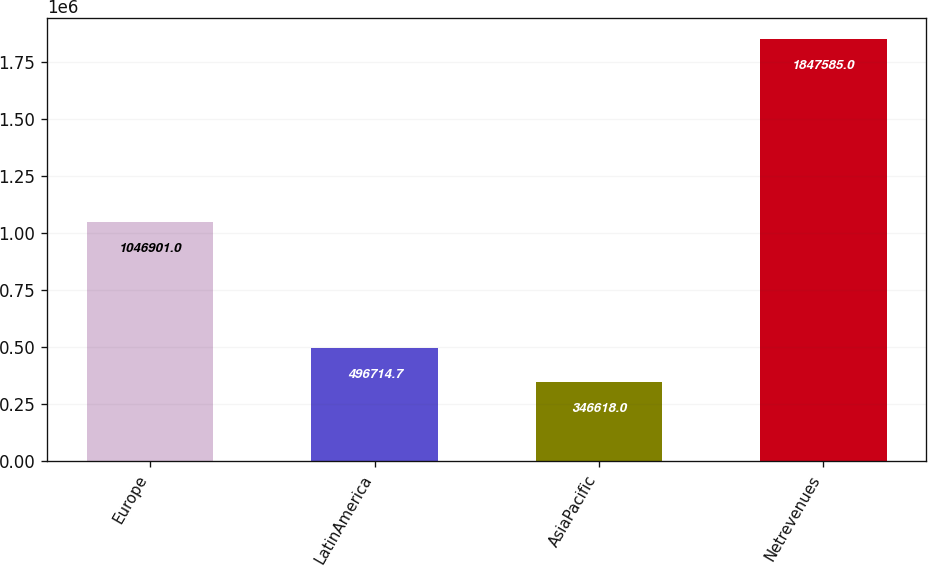Convert chart to OTSL. <chart><loc_0><loc_0><loc_500><loc_500><bar_chart><fcel>Europe<fcel>LatinAmerica<fcel>AsiaPacific<fcel>Netrevenues<nl><fcel>1.0469e+06<fcel>496715<fcel>346618<fcel>1.84758e+06<nl></chart> 